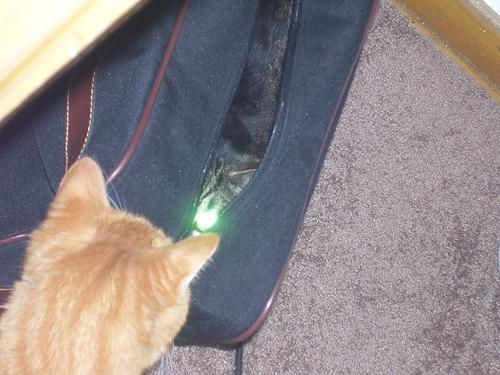Question: what is in the bag?
Choices:
A. A cat.
B. Wallet.
C. Food.
D. Dog.
Answer with the letter. Answer: A Question: what color is the carpet?
Choices:
A. Red.
B. Orange.
C. Green.
D. Purple.
Answer with the letter. Answer: D Question: how many people are in the photo?
Choices:
A. 5.
B. 0.
C. 2.
D. 3.
Answer with the letter. Answer: B 